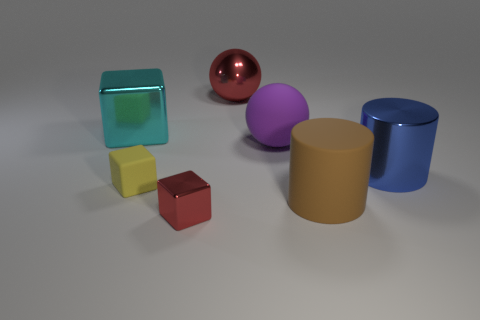Add 1 big yellow metallic cylinders. How many objects exist? 8 Subtract all small cubes. How many cubes are left? 1 Subtract 1 cylinders. How many cylinders are left? 1 Subtract all cyan cubes. How many cubes are left? 2 Subtract all cylinders. How many objects are left? 5 Subtract all small red cubes. Subtract all small red metal things. How many objects are left? 5 Add 7 red metallic balls. How many red metallic balls are left? 8 Add 6 big red spheres. How many big red spheres exist? 7 Subtract 0 purple cubes. How many objects are left? 7 Subtract all gray blocks. Subtract all cyan spheres. How many blocks are left? 3 